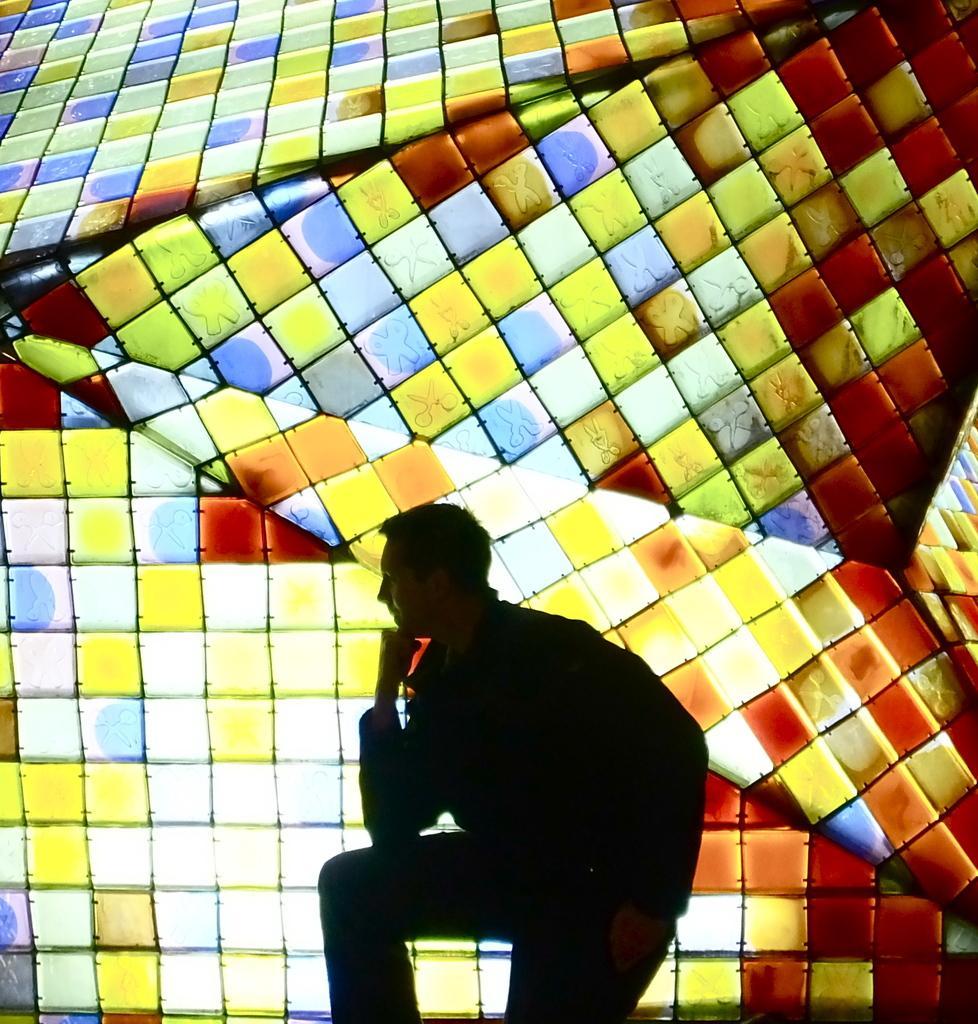Describe this image in one or two sentences. In the foreground of this image, there is a man standing. Behind him, there is a 3D painting glass wall. 